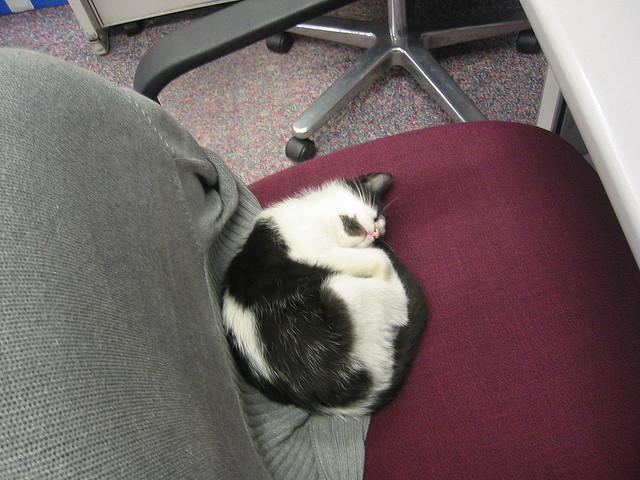How many chairs are in the picture?
Give a very brief answer. 2. 